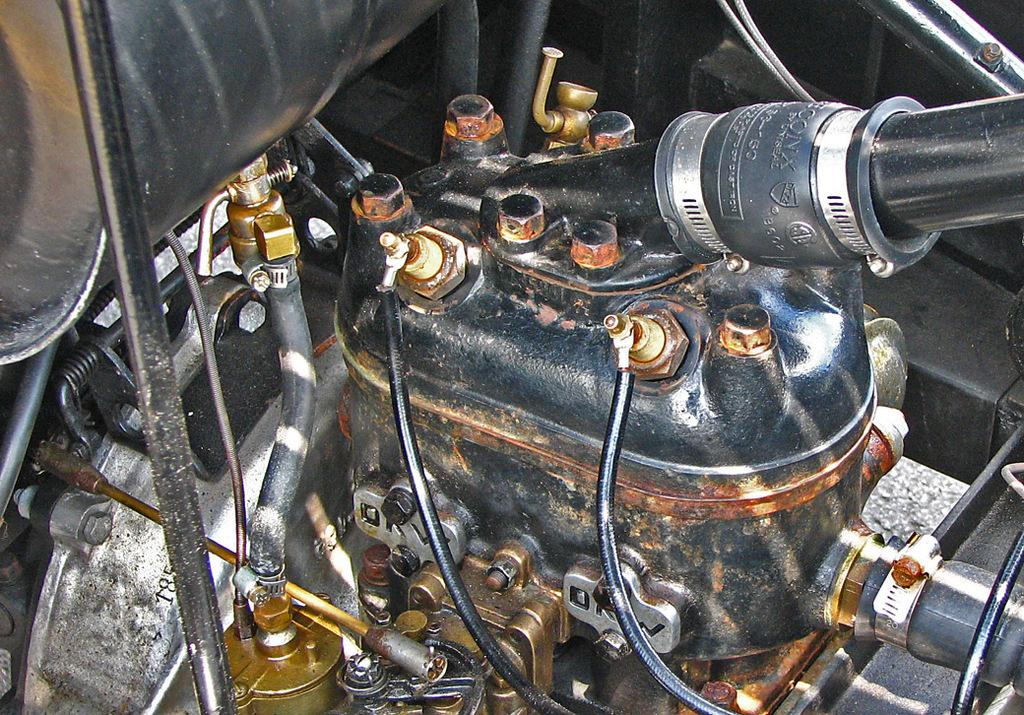What type of object is the main subject of the image? There is a spare part of a motor vehicle in the image. How many ducks are swimming in the cork in the image? There are no ducks or cork present in the image; it features a spare part of a motor vehicle. 